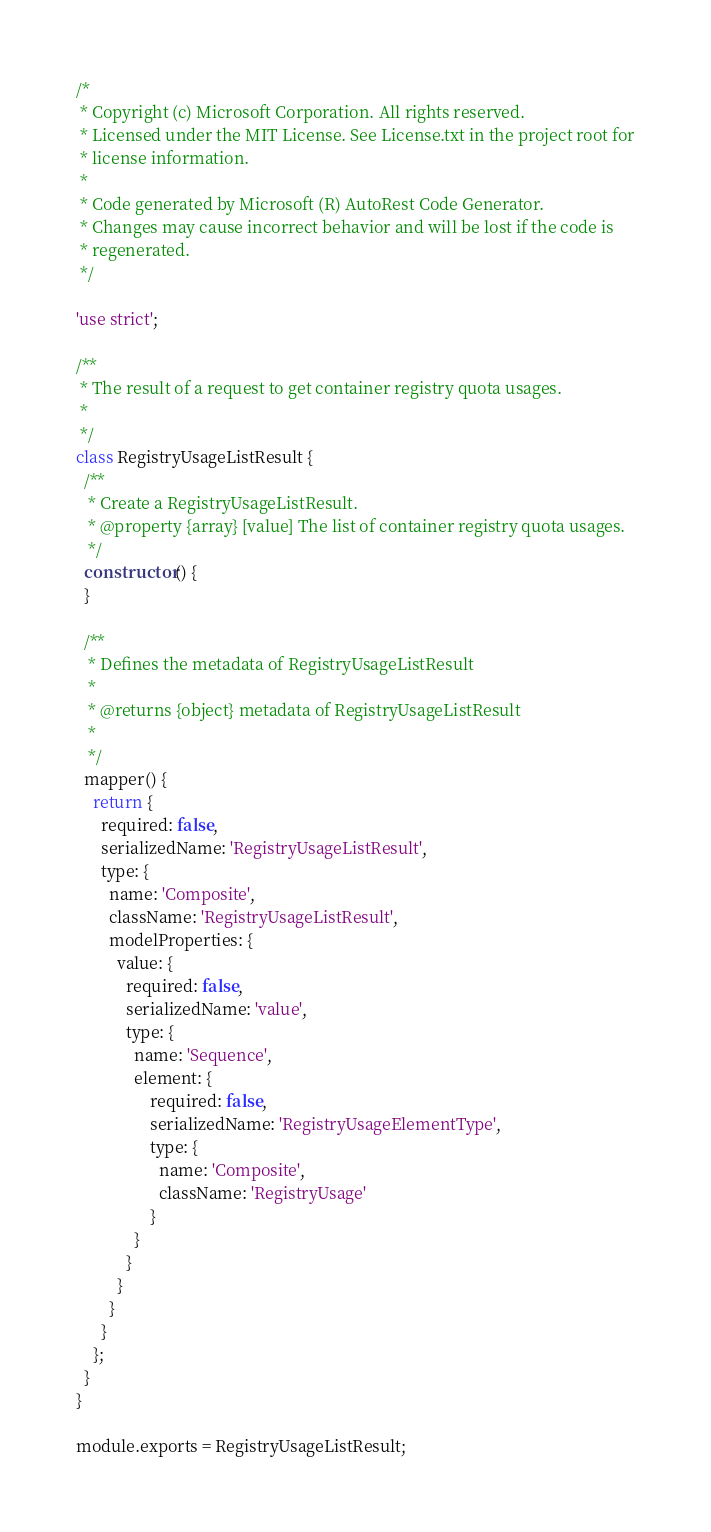Convert code to text. <code><loc_0><loc_0><loc_500><loc_500><_JavaScript_>/*
 * Copyright (c) Microsoft Corporation. All rights reserved.
 * Licensed under the MIT License. See License.txt in the project root for
 * license information.
 *
 * Code generated by Microsoft (R) AutoRest Code Generator.
 * Changes may cause incorrect behavior and will be lost if the code is
 * regenerated.
 */

'use strict';

/**
 * The result of a request to get container registry quota usages.
 *
 */
class RegistryUsageListResult {
  /**
   * Create a RegistryUsageListResult.
   * @property {array} [value] The list of container registry quota usages.
   */
  constructor() {
  }

  /**
   * Defines the metadata of RegistryUsageListResult
   *
   * @returns {object} metadata of RegistryUsageListResult
   *
   */
  mapper() {
    return {
      required: false,
      serializedName: 'RegistryUsageListResult',
      type: {
        name: 'Composite',
        className: 'RegistryUsageListResult',
        modelProperties: {
          value: {
            required: false,
            serializedName: 'value',
            type: {
              name: 'Sequence',
              element: {
                  required: false,
                  serializedName: 'RegistryUsageElementType',
                  type: {
                    name: 'Composite',
                    className: 'RegistryUsage'
                  }
              }
            }
          }
        }
      }
    };
  }
}

module.exports = RegistryUsageListResult;
</code> 